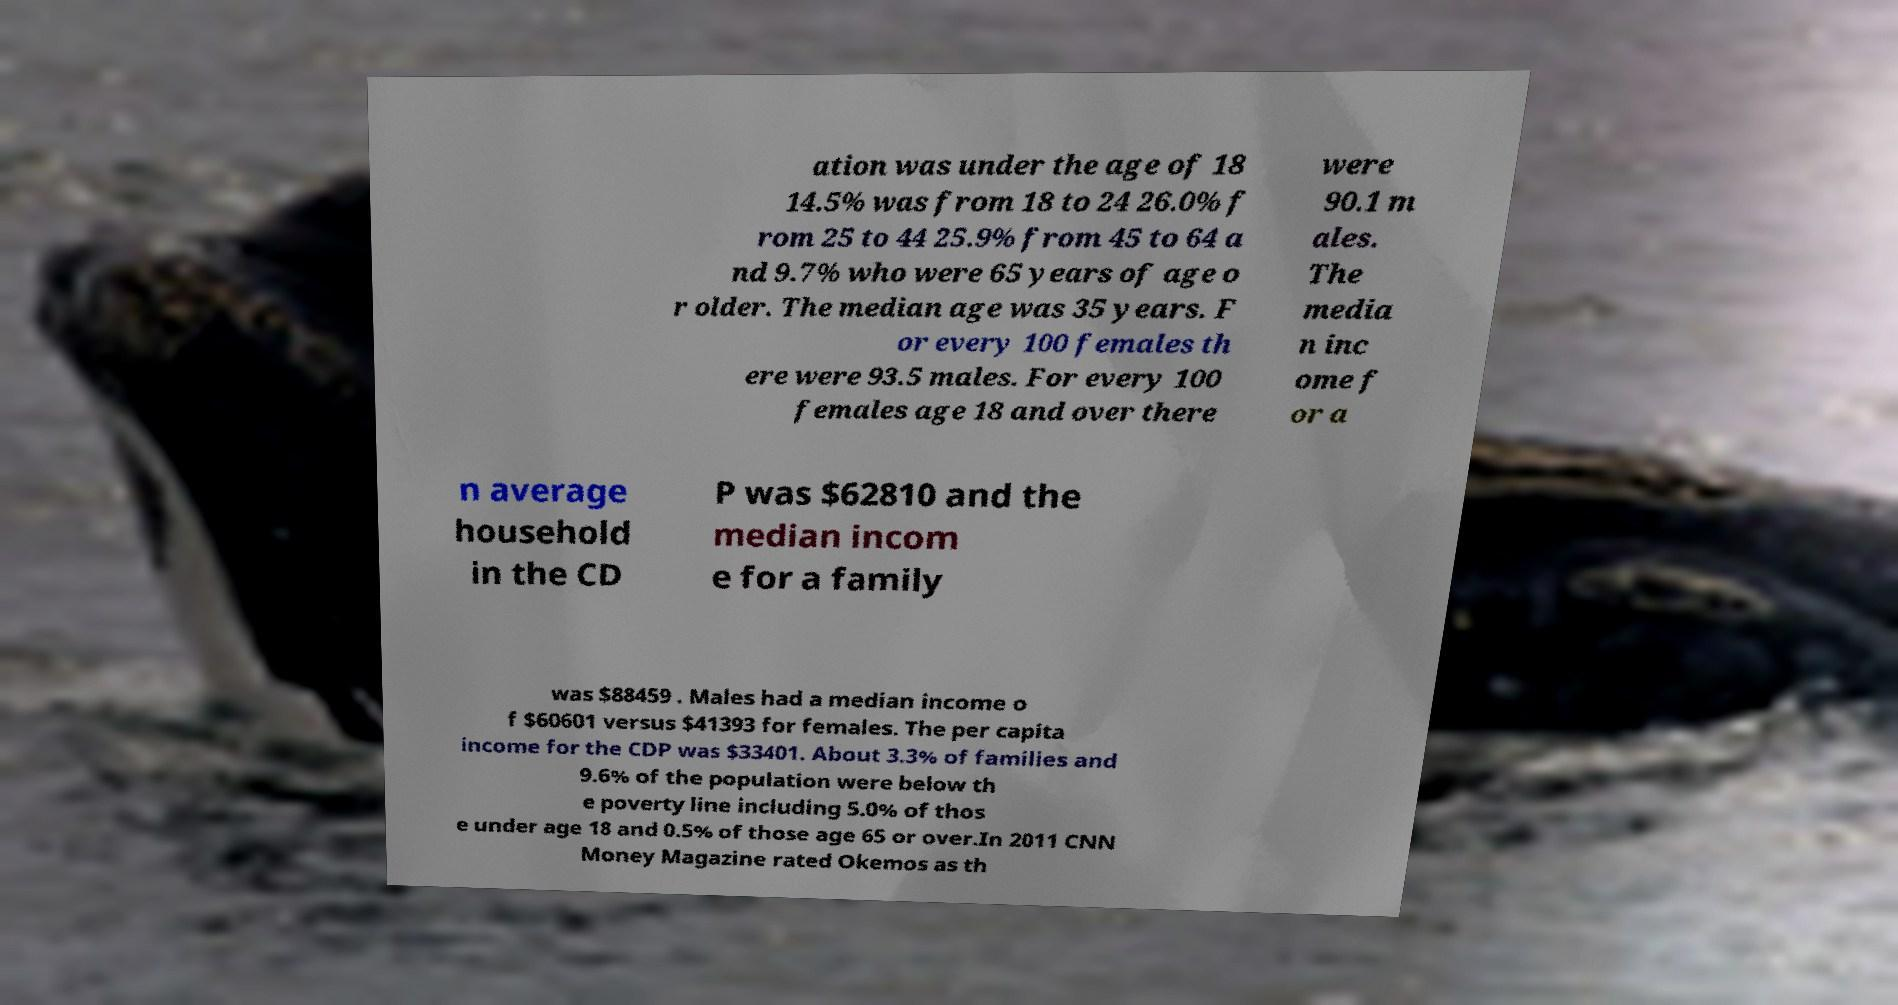I need the written content from this picture converted into text. Can you do that? ation was under the age of 18 14.5% was from 18 to 24 26.0% f rom 25 to 44 25.9% from 45 to 64 a nd 9.7% who were 65 years of age o r older. The median age was 35 years. F or every 100 females th ere were 93.5 males. For every 100 females age 18 and over there were 90.1 m ales. The media n inc ome f or a n average household in the CD P was $62810 and the median incom e for a family was $88459 . Males had a median income o f $60601 versus $41393 for females. The per capita income for the CDP was $33401. About 3.3% of families and 9.6% of the population were below th e poverty line including 5.0% of thos e under age 18 and 0.5% of those age 65 or over.In 2011 CNN Money Magazine rated Okemos as th 